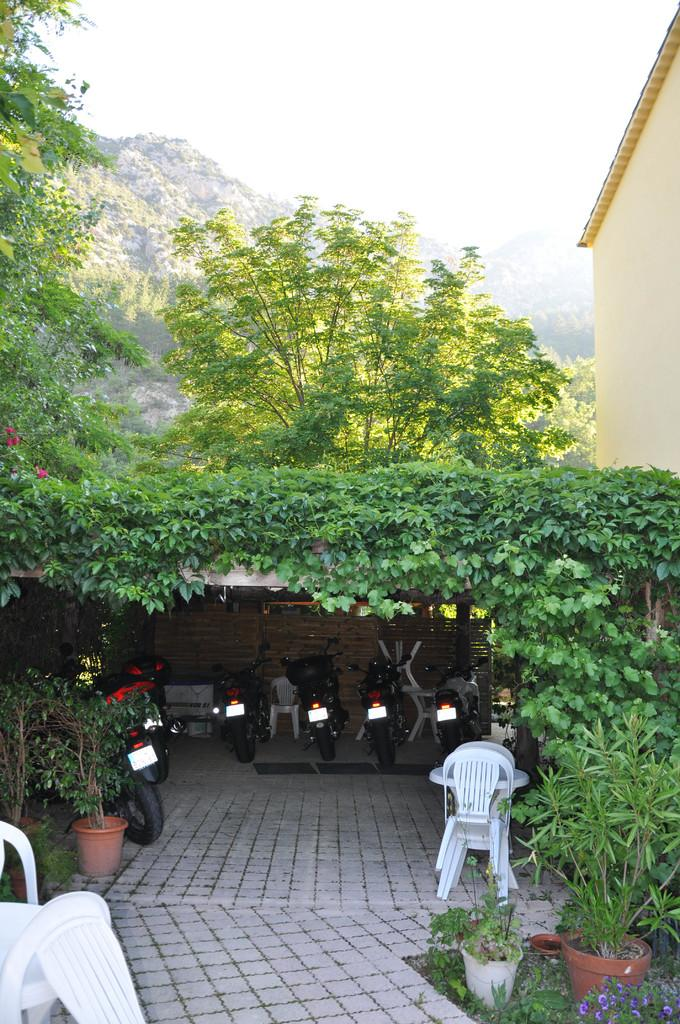What type of vehicles are on the ground in the image? There is a group of motorcycles on the ground in the image. What type of natural elements can be seen in the image? There are trees in the image. What type of decorative items are present in the image? There are flower pots in the image. What type of furniture can be seen in the image? There are chairs in the image. What is visible in the background of the image? The sky is visible in the image. What type of pin can be seen holding the earth in the image? There is no pin or earth present in the image; it only features motorcycles, trees, flower pots, chairs, and the sky. What type of loaf is being used as a table for the motorcycles in the image? There is no loaf present in the image; the motorcycles are on the ground, and there is no table or loaf mentioned. 